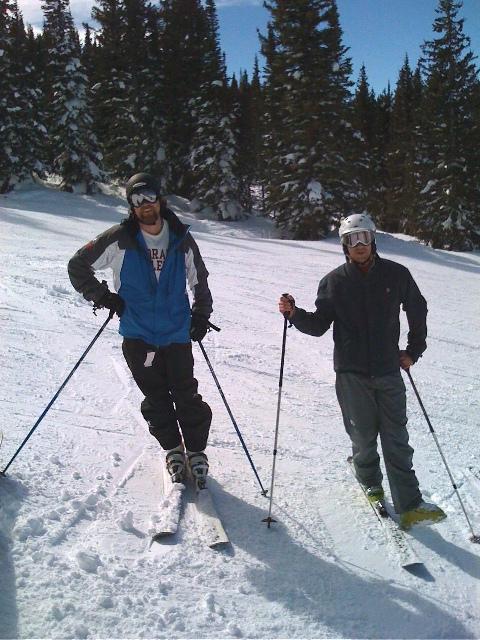How many people are holding ski poles?
Select the accurate answer and provide justification: `Answer: choice
Rationale: srationale.`
Options: Four, six, two, five. Answer: two.
Rationale: There are two people standing on the ski slope holding ski poles. 